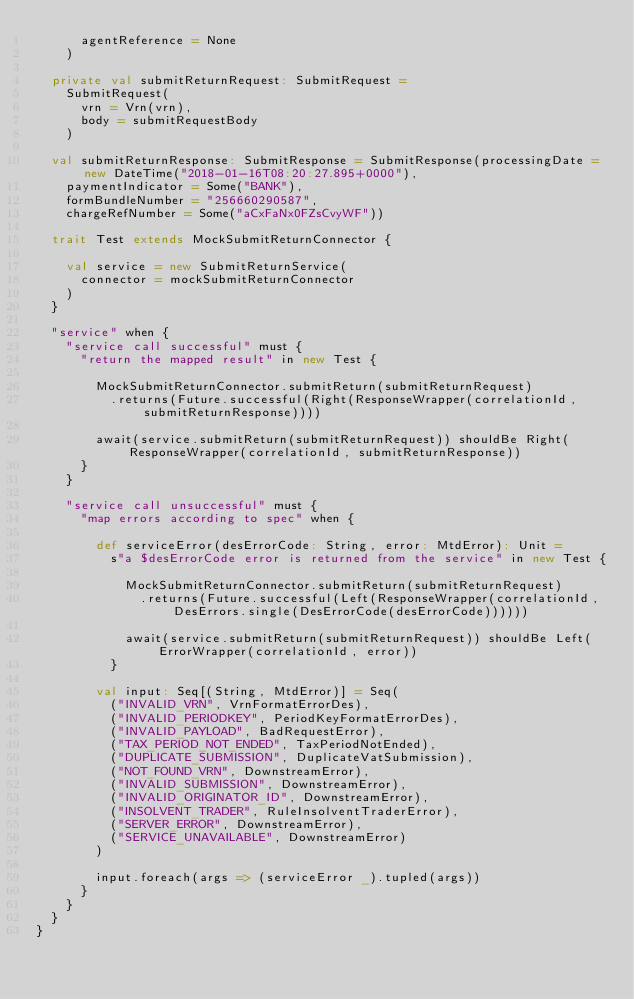<code> <loc_0><loc_0><loc_500><loc_500><_Scala_>      agentReference = None
    )

  private val submitReturnRequest: SubmitRequest =
    SubmitRequest(
      vrn = Vrn(vrn),
      body = submitRequestBody
    )

  val submitReturnResponse: SubmitResponse = SubmitResponse(processingDate = new DateTime("2018-01-16T08:20:27.895+0000"),
    paymentIndicator = Some("BANK"),
    formBundleNumber = "256660290587",
    chargeRefNumber = Some("aCxFaNx0FZsCvyWF"))

  trait Test extends MockSubmitReturnConnector {

    val service = new SubmitReturnService(
      connector = mockSubmitReturnConnector
    )
  }

  "service" when {
    "service call successful" must {
      "return the mapped result" in new Test {

        MockSubmitReturnConnector.submitReturn(submitReturnRequest)
          .returns(Future.successful(Right(ResponseWrapper(correlationId, submitReturnResponse))))

        await(service.submitReturn(submitReturnRequest)) shouldBe Right(ResponseWrapper(correlationId, submitReturnResponse))
      }
    }

    "service call unsuccessful" must {
      "map errors according to spec" when {

        def serviceError(desErrorCode: String, error: MtdError): Unit =
          s"a $desErrorCode error is returned from the service" in new Test {

            MockSubmitReturnConnector.submitReturn(submitReturnRequest)
              .returns(Future.successful(Left(ResponseWrapper(correlationId, DesErrors.single(DesErrorCode(desErrorCode))))))

            await(service.submitReturn(submitReturnRequest)) shouldBe Left(ErrorWrapper(correlationId, error))
          }

        val input: Seq[(String, MtdError)] = Seq(
          ("INVALID_VRN", VrnFormatErrorDes),
          ("INVALID_PERIODKEY", PeriodKeyFormatErrorDes),
          ("INVALID_PAYLOAD", BadRequestError),
          ("TAX_PERIOD_NOT_ENDED", TaxPeriodNotEnded),
          ("DUPLICATE_SUBMISSION", DuplicateVatSubmission),
          ("NOT_FOUND_VRN", DownstreamError),
          ("INVALID_SUBMISSION", DownstreamError),
          ("INVALID_ORIGINATOR_ID", DownstreamError),
          ("INSOLVENT_TRADER", RuleInsolventTraderError),
          ("SERVER_ERROR", DownstreamError),
          ("SERVICE_UNAVAILABLE", DownstreamError)
        )

        input.foreach(args => (serviceError _).tupled(args))
      }
    }
  }
}
</code> 